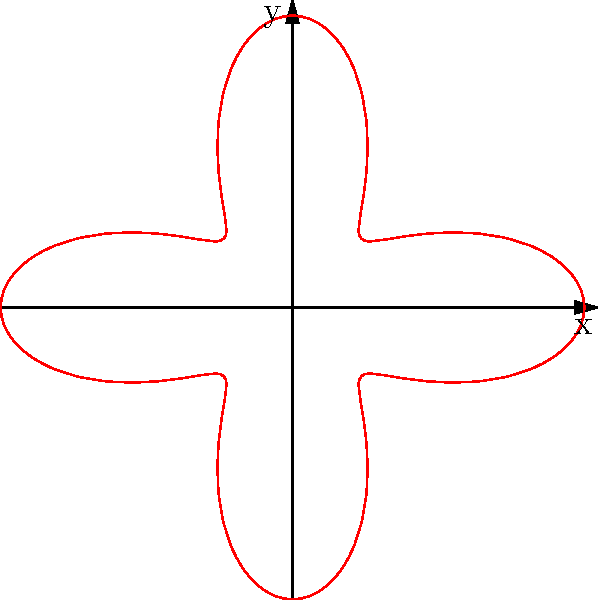As a cashier at a fast-food restaurant, you notice that the new logo resembles a polar curve. The equation of this curve is given by $r = 1 + 0.5\cos(4\theta)$. How many "petals" or lobes does this logo have? To determine the number of petals or lobes in the polar curve, we need to follow these steps:

1. Recognize that the general form of the equation is $r = a + b\cos(n\theta)$, where $n$ determines the number of petals.

2. In our equation $r = 1 + 0.5\cos(4\theta)$:
   $a = 1$
   $b = 0.5$
   $n = 4$

3. For curves of this form, the number of petals is equal to $n$ if $n$ is even.

4. Since $n = 4$, which is even, the number of petals is equal to 4.

5. We can verify this by looking at the graph, which clearly shows 4 lobes or petals.

Therefore, the logo has 4 petals or lobes.
Answer: 4 petals 